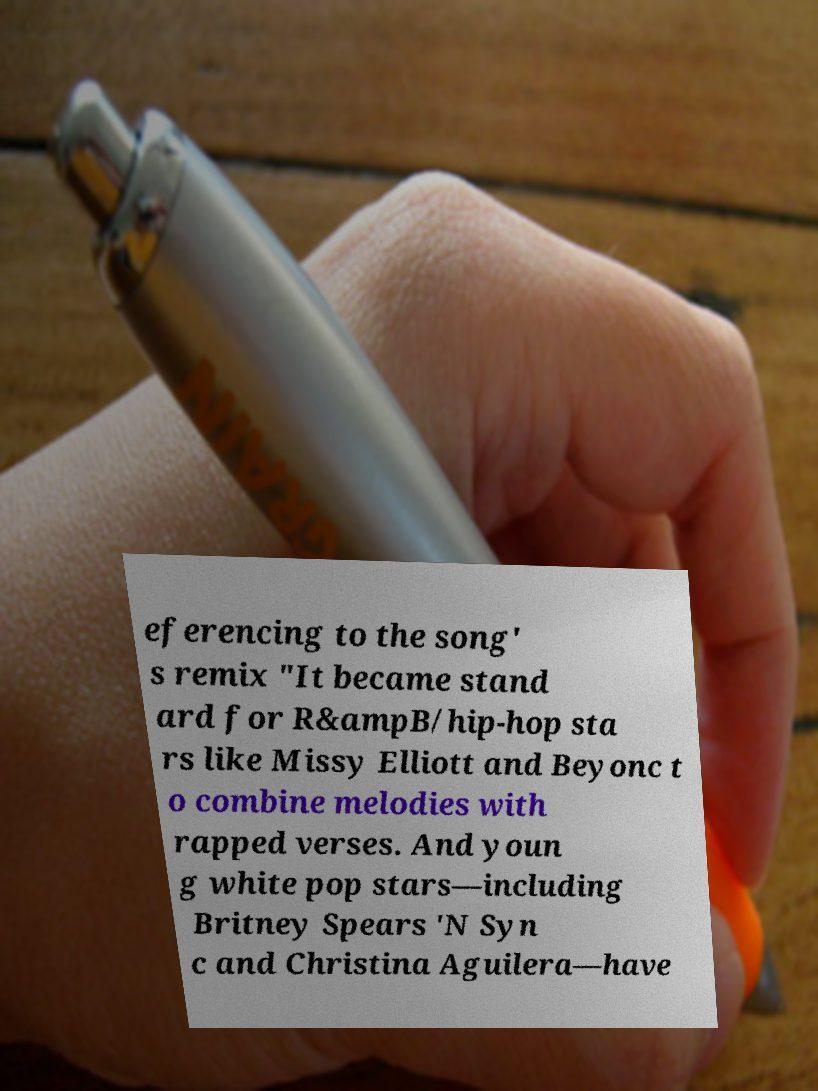Please read and relay the text visible in this image. What does it say? eferencing to the song' s remix "It became stand ard for R&ampB/hip-hop sta rs like Missy Elliott and Beyonc t o combine melodies with rapped verses. And youn g white pop stars—including Britney Spears 'N Syn c and Christina Aguilera—have 